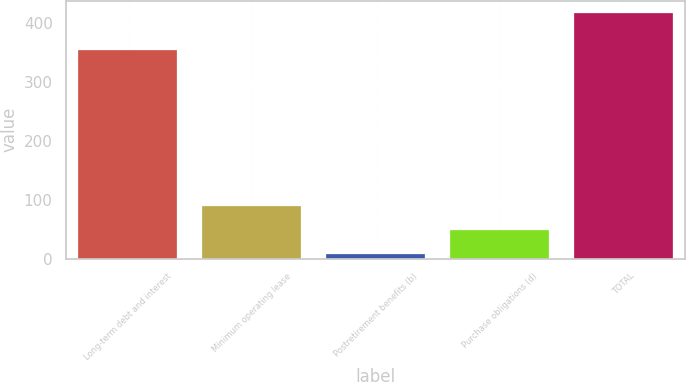Convert chart to OTSL. <chart><loc_0><loc_0><loc_500><loc_500><bar_chart><fcel>Long-term debt and interest<fcel>Minimum operating lease<fcel>Postretirement benefits (b)<fcel>Purchase obligations (d)<fcel>TOTAL<nl><fcel>354<fcel>89.22<fcel>7.2<fcel>48.21<fcel>417.3<nl></chart> 